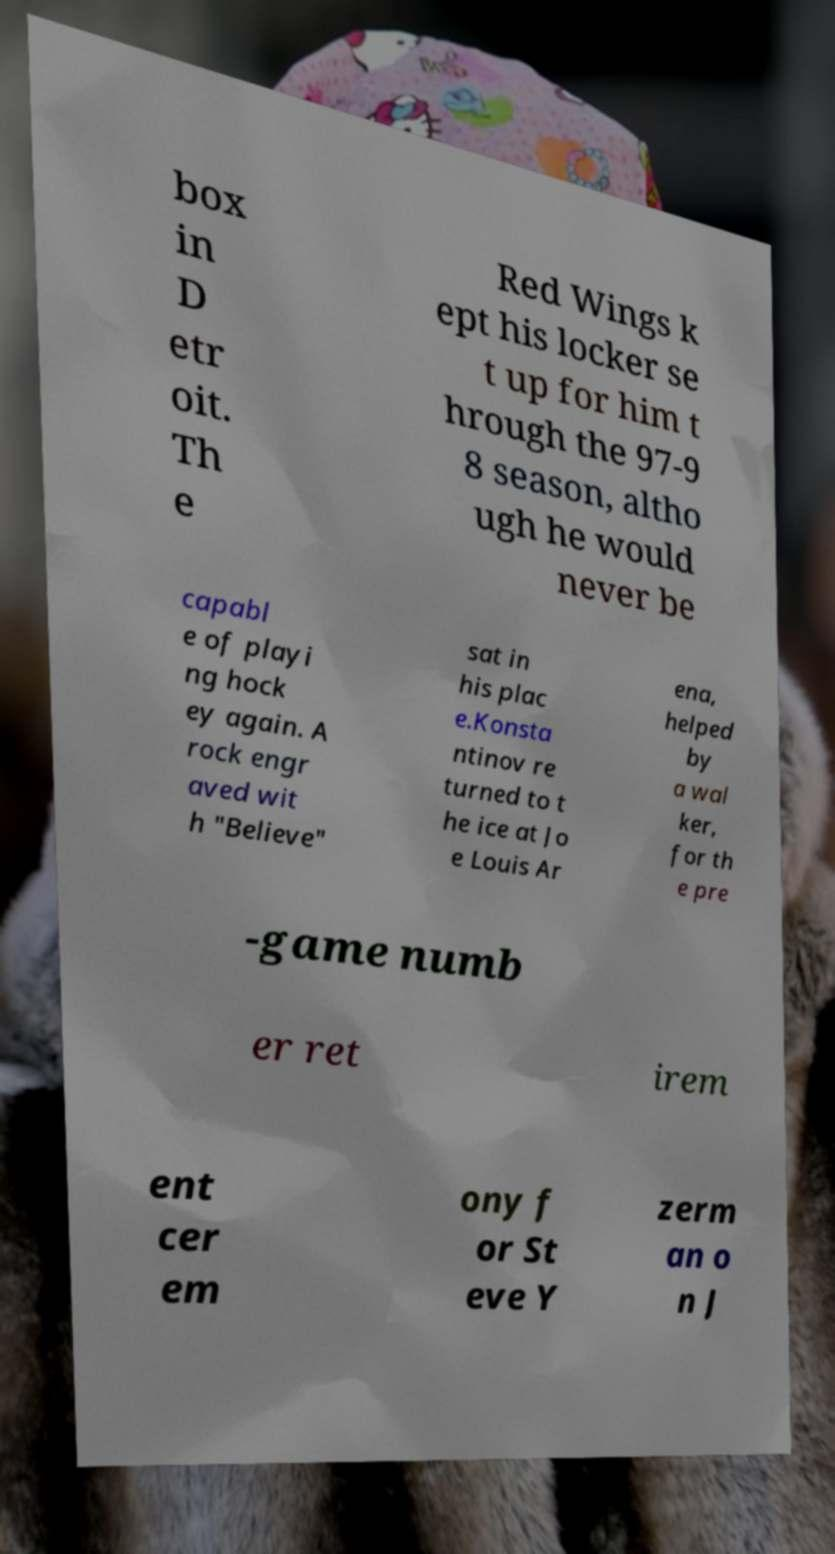Could you assist in decoding the text presented in this image and type it out clearly? box in D etr oit. Th e Red Wings k ept his locker se t up for him t hrough the 97-9 8 season, altho ugh he would never be capabl e of playi ng hock ey again. A rock engr aved wit h "Believe" sat in his plac e.Konsta ntinov re turned to t he ice at Jo e Louis Ar ena, helped by a wal ker, for th e pre -game numb er ret irem ent cer em ony f or St eve Y zerm an o n J 